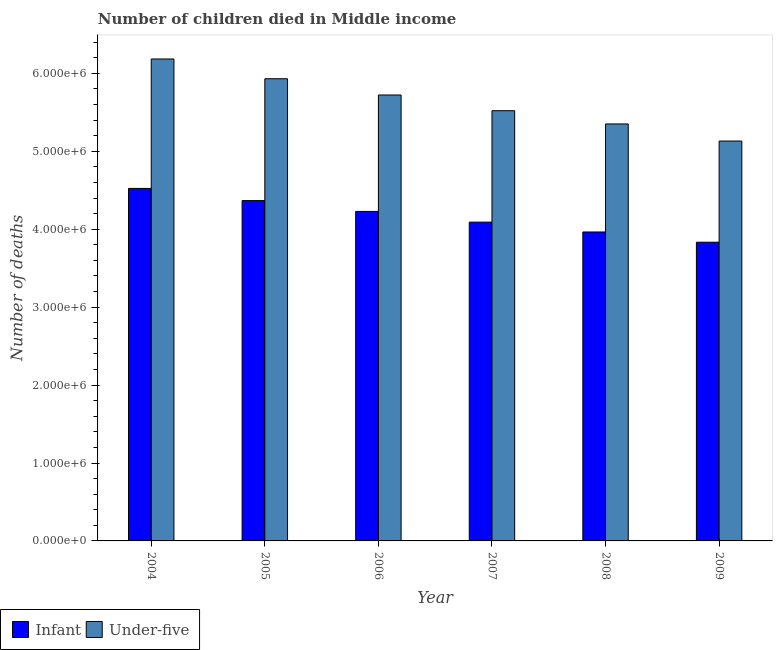How many different coloured bars are there?
Provide a succinct answer. 2. How many groups of bars are there?
Give a very brief answer. 6. Are the number of bars on each tick of the X-axis equal?
Provide a short and direct response. Yes. What is the label of the 1st group of bars from the left?
Make the answer very short. 2004. What is the number of under-five deaths in 2007?
Keep it short and to the point. 5.52e+06. Across all years, what is the maximum number of under-five deaths?
Provide a short and direct response. 6.19e+06. Across all years, what is the minimum number of under-five deaths?
Provide a succinct answer. 5.13e+06. In which year was the number of under-five deaths maximum?
Your response must be concise. 2004. What is the total number of infant deaths in the graph?
Make the answer very short. 2.50e+07. What is the difference between the number of under-five deaths in 2004 and that in 2008?
Your answer should be very brief. 8.34e+05. What is the difference between the number of infant deaths in 2005 and the number of under-five deaths in 2004?
Offer a terse response. -1.56e+05. What is the average number of infant deaths per year?
Your answer should be compact. 4.17e+06. In the year 2006, what is the difference between the number of infant deaths and number of under-five deaths?
Provide a short and direct response. 0. What is the ratio of the number of infant deaths in 2007 to that in 2008?
Provide a succinct answer. 1.03. What is the difference between the highest and the second highest number of under-five deaths?
Your response must be concise. 2.54e+05. What is the difference between the highest and the lowest number of infant deaths?
Keep it short and to the point. 6.90e+05. In how many years, is the number of under-five deaths greater than the average number of under-five deaths taken over all years?
Give a very brief answer. 3. What does the 1st bar from the left in 2007 represents?
Your answer should be compact. Infant. What does the 1st bar from the right in 2007 represents?
Keep it short and to the point. Under-five. Are all the bars in the graph horizontal?
Keep it short and to the point. No. What is the difference between two consecutive major ticks on the Y-axis?
Provide a short and direct response. 1.00e+06. Does the graph contain any zero values?
Your answer should be compact. No. Does the graph contain grids?
Give a very brief answer. No. What is the title of the graph?
Provide a short and direct response. Number of children died in Middle income. Does "Netherlands" appear as one of the legend labels in the graph?
Provide a succinct answer. No. What is the label or title of the X-axis?
Give a very brief answer. Year. What is the label or title of the Y-axis?
Offer a very short reply. Number of deaths. What is the Number of deaths of Infant in 2004?
Offer a terse response. 4.52e+06. What is the Number of deaths in Under-five in 2004?
Offer a very short reply. 6.19e+06. What is the Number of deaths of Infant in 2005?
Your response must be concise. 4.37e+06. What is the Number of deaths in Under-five in 2005?
Give a very brief answer. 5.93e+06. What is the Number of deaths in Infant in 2006?
Make the answer very short. 4.23e+06. What is the Number of deaths of Under-five in 2006?
Make the answer very short. 5.72e+06. What is the Number of deaths in Infant in 2007?
Give a very brief answer. 4.09e+06. What is the Number of deaths in Under-five in 2007?
Ensure brevity in your answer.  5.52e+06. What is the Number of deaths in Infant in 2008?
Your response must be concise. 3.97e+06. What is the Number of deaths in Under-five in 2008?
Give a very brief answer. 5.35e+06. What is the Number of deaths in Infant in 2009?
Keep it short and to the point. 3.83e+06. What is the Number of deaths in Under-five in 2009?
Offer a terse response. 5.13e+06. Across all years, what is the maximum Number of deaths in Infant?
Provide a succinct answer. 4.52e+06. Across all years, what is the maximum Number of deaths of Under-five?
Your answer should be very brief. 6.19e+06. Across all years, what is the minimum Number of deaths of Infant?
Keep it short and to the point. 3.83e+06. Across all years, what is the minimum Number of deaths of Under-five?
Offer a terse response. 5.13e+06. What is the total Number of deaths in Infant in the graph?
Your answer should be compact. 2.50e+07. What is the total Number of deaths of Under-five in the graph?
Your answer should be very brief. 3.38e+07. What is the difference between the Number of deaths in Infant in 2004 and that in 2005?
Your answer should be compact. 1.56e+05. What is the difference between the Number of deaths of Under-five in 2004 and that in 2005?
Your answer should be very brief. 2.54e+05. What is the difference between the Number of deaths in Infant in 2004 and that in 2006?
Make the answer very short. 2.95e+05. What is the difference between the Number of deaths of Under-five in 2004 and that in 2006?
Offer a very short reply. 4.62e+05. What is the difference between the Number of deaths in Infant in 2004 and that in 2007?
Your answer should be very brief. 4.33e+05. What is the difference between the Number of deaths in Under-five in 2004 and that in 2007?
Provide a short and direct response. 6.64e+05. What is the difference between the Number of deaths of Infant in 2004 and that in 2008?
Ensure brevity in your answer.  5.59e+05. What is the difference between the Number of deaths in Under-five in 2004 and that in 2008?
Make the answer very short. 8.34e+05. What is the difference between the Number of deaths of Infant in 2004 and that in 2009?
Ensure brevity in your answer.  6.90e+05. What is the difference between the Number of deaths in Under-five in 2004 and that in 2009?
Provide a succinct answer. 1.05e+06. What is the difference between the Number of deaths in Infant in 2005 and that in 2006?
Your answer should be compact. 1.39e+05. What is the difference between the Number of deaths of Under-five in 2005 and that in 2006?
Offer a very short reply. 2.09e+05. What is the difference between the Number of deaths in Infant in 2005 and that in 2007?
Keep it short and to the point. 2.76e+05. What is the difference between the Number of deaths in Under-five in 2005 and that in 2007?
Offer a very short reply. 4.10e+05. What is the difference between the Number of deaths of Infant in 2005 and that in 2008?
Offer a very short reply. 4.03e+05. What is the difference between the Number of deaths in Under-five in 2005 and that in 2008?
Give a very brief answer. 5.80e+05. What is the difference between the Number of deaths of Infant in 2005 and that in 2009?
Keep it short and to the point. 5.34e+05. What is the difference between the Number of deaths in Under-five in 2005 and that in 2009?
Your answer should be very brief. 8.00e+05. What is the difference between the Number of deaths of Infant in 2006 and that in 2007?
Your answer should be compact. 1.37e+05. What is the difference between the Number of deaths in Under-five in 2006 and that in 2007?
Your response must be concise. 2.01e+05. What is the difference between the Number of deaths of Infant in 2006 and that in 2008?
Provide a short and direct response. 2.64e+05. What is the difference between the Number of deaths in Under-five in 2006 and that in 2008?
Give a very brief answer. 3.72e+05. What is the difference between the Number of deaths of Infant in 2006 and that in 2009?
Your answer should be compact. 3.95e+05. What is the difference between the Number of deaths of Under-five in 2006 and that in 2009?
Offer a terse response. 5.91e+05. What is the difference between the Number of deaths in Infant in 2007 and that in 2008?
Your answer should be compact. 1.26e+05. What is the difference between the Number of deaths in Under-five in 2007 and that in 2008?
Keep it short and to the point. 1.70e+05. What is the difference between the Number of deaths in Infant in 2007 and that in 2009?
Provide a succinct answer. 2.58e+05. What is the difference between the Number of deaths of Under-five in 2007 and that in 2009?
Make the answer very short. 3.90e+05. What is the difference between the Number of deaths in Infant in 2008 and that in 2009?
Provide a succinct answer. 1.31e+05. What is the difference between the Number of deaths of Under-five in 2008 and that in 2009?
Your response must be concise. 2.19e+05. What is the difference between the Number of deaths in Infant in 2004 and the Number of deaths in Under-five in 2005?
Your answer should be very brief. -1.41e+06. What is the difference between the Number of deaths in Infant in 2004 and the Number of deaths in Under-five in 2006?
Provide a succinct answer. -1.20e+06. What is the difference between the Number of deaths of Infant in 2004 and the Number of deaths of Under-five in 2007?
Make the answer very short. -9.97e+05. What is the difference between the Number of deaths in Infant in 2004 and the Number of deaths in Under-five in 2008?
Your answer should be compact. -8.27e+05. What is the difference between the Number of deaths of Infant in 2004 and the Number of deaths of Under-five in 2009?
Offer a terse response. -6.08e+05. What is the difference between the Number of deaths in Infant in 2005 and the Number of deaths in Under-five in 2006?
Your answer should be very brief. -1.36e+06. What is the difference between the Number of deaths of Infant in 2005 and the Number of deaths of Under-five in 2007?
Offer a terse response. -1.15e+06. What is the difference between the Number of deaths of Infant in 2005 and the Number of deaths of Under-five in 2008?
Make the answer very short. -9.84e+05. What is the difference between the Number of deaths of Infant in 2005 and the Number of deaths of Under-five in 2009?
Your answer should be very brief. -7.64e+05. What is the difference between the Number of deaths in Infant in 2006 and the Number of deaths in Under-five in 2007?
Offer a terse response. -1.29e+06. What is the difference between the Number of deaths in Infant in 2006 and the Number of deaths in Under-five in 2008?
Your response must be concise. -1.12e+06. What is the difference between the Number of deaths of Infant in 2006 and the Number of deaths of Under-five in 2009?
Give a very brief answer. -9.03e+05. What is the difference between the Number of deaths in Infant in 2007 and the Number of deaths in Under-five in 2008?
Your answer should be very brief. -1.26e+06. What is the difference between the Number of deaths of Infant in 2007 and the Number of deaths of Under-five in 2009?
Provide a short and direct response. -1.04e+06. What is the difference between the Number of deaths of Infant in 2008 and the Number of deaths of Under-five in 2009?
Make the answer very short. -1.17e+06. What is the average Number of deaths of Infant per year?
Make the answer very short. 4.17e+06. What is the average Number of deaths of Under-five per year?
Your response must be concise. 5.64e+06. In the year 2004, what is the difference between the Number of deaths of Infant and Number of deaths of Under-five?
Provide a short and direct response. -1.66e+06. In the year 2005, what is the difference between the Number of deaths in Infant and Number of deaths in Under-five?
Offer a very short reply. -1.56e+06. In the year 2006, what is the difference between the Number of deaths in Infant and Number of deaths in Under-five?
Keep it short and to the point. -1.49e+06. In the year 2007, what is the difference between the Number of deaths of Infant and Number of deaths of Under-five?
Your response must be concise. -1.43e+06. In the year 2008, what is the difference between the Number of deaths in Infant and Number of deaths in Under-five?
Your response must be concise. -1.39e+06. In the year 2009, what is the difference between the Number of deaths of Infant and Number of deaths of Under-five?
Give a very brief answer. -1.30e+06. What is the ratio of the Number of deaths in Infant in 2004 to that in 2005?
Your response must be concise. 1.04. What is the ratio of the Number of deaths in Under-five in 2004 to that in 2005?
Offer a terse response. 1.04. What is the ratio of the Number of deaths in Infant in 2004 to that in 2006?
Keep it short and to the point. 1.07. What is the ratio of the Number of deaths of Under-five in 2004 to that in 2006?
Keep it short and to the point. 1.08. What is the ratio of the Number of deaths in Infant in 2004 to that in 2007?
Make the answer very short. 1.11. What is the ratio of the Number of deaths in Under-five in 2004 to that in 2007?
Your response must be concise. 1.12. What is the ratio of the Number of deaths of Infant in 2004 to that in 2008?
Provide a short and direct response. 1.14. What is the ratio of the Number of deaths in Under-five in 2004 to that in 2008?
Make the answer very short. 1.16. What is the ratio of the Number of deaths of Infant in 2004 to that in 2009?
Your answer should be compact. 1.18. What is the ratio of the Number of deaths of Under-five in 2004 to that in 2009?
Your answer should be very brief. 1.21. What is the ratio of the Number of deaths in Infant in 2005 to that in 2006?
Give a very brief answer. 1.03. What is the ratio of the Number of deaths of Under-five in 2005 to that in 2006?
Give a very brief answer. 1.04. What is the ratio of the Number of deaths in Infant in 2005 to that in 2007?
Offer a very short reply. 1.07. What is the ratio of the Number of deaths in Under-five in 2005 to that in 2007?
Ensure brevity in your answer.  1.07. What is the ratio of the Number of deaths of Infant in 2005 to that in 2008?
Your answer should be very brief. 1.1. What is the ratio of the Number of deaths of Under-five in 2005 to that in 2008?
Your response must be concise. 1.11. What is the ratio of the Number of deaths in Infant in 2005 to that in 2009?
Your answer should be compact. 1.14. What is the ratio of the Number of deaths of Under-five in 2005 to that in 2009?
Ensure brevity in your answer.  1.16. What is the ratio of the Number of deaths in Infant in 2006 to that in 2007?
Offer a terse response. 1.03. What is the ratio of the Number of deaths in Under-five in 2006 to that in 2007?
Make the answer very short. 1.04. What is the ratio of the Number of deaths of Infant in 2006 to that in 2008?
Offer a very short reply. 1.07. What is the ratio of the Number of deaths of Under-five in 2006 to that in 2008?
Your response must be concise. 1.07. What is the ratio of the Number of deaths of Infant in 2006 to that in 2009?
Provide a succinct answer. 1.1. What is the ratio of the Number of deaths of Under-five in 2006 to that in 2009?
Provide a succinct answer. 1.12. What is the ratio of the Number of deaths in Infant in 2007 to that in 2008?
Offer a terse response. 1.03. What is the ratio of the Number of deaths of Under-five in 2007 to that in 2008?
Make the answer very short. 1.03. What is the ratio of the Number of deaths of Infant in 2007 to that in 2009?
Give a very brief answer. 1.07. What is the ratio of the Number of deaths in Under-five in 2007 to that in 2009?
Give a very brief answer. 1.08. What is the ratio of the Number of deaths in Infant in 2008 to that in 2009?
Make the answer very short. 1.03. What is the ratio of the Number of deaths in Under-five in 2008 to that in 2009?
Your answer should be very brief. 1.04. What is the difference between the highest and the second highest Number of deaths of Infant?
Offer a terse response. 1.56e+05. What is the difference between the highest and the second highest Number of deaths in Under-five?
Ensure brevity in your answer.  2.54e+05. What is the difference between the highest and the lowest Number of deaths in Infant?
Your response must be concise. 6.90e+05. What is the difference between the highest and the lowest Number of deaths in Under-five?
Offer a very short reply. 1.05e+06. 